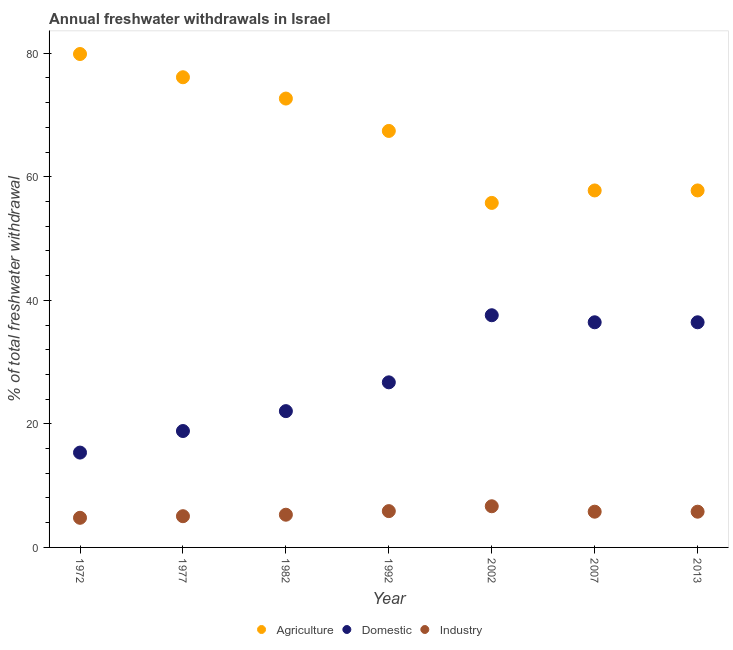Is the number of dotlines equal to the number of legend labels?
Keep it short and to the point. Yes. What is the percentage of freshwater withdrawal for agriculture in 1992?
Ensure brevity in your answer.  67.41. Across all years, what is the maximum percentage of freshwater withdrawal for agriculture?
Provide a succinct answer. 79.86. Across all years, what is the minimum percentage of freshwater withdrawal for agriculture?
Your response must be concise. 55.76. In which year was the percentage of freshwater withdrawal for industry maximum?
Your response must be concise. 2002. In which year was the percentage of freshwater withdrawal for industry minimum?
Your answer should be compact. 1972. What is the total percentage of freshwater withdrawal for industry in the graph?
Provide a short and direct response. 39.25. What is the difference between the percentage of freshwater withdrawal for domestic purposes in 1972 and that in 1982?
Offer a terse response. -6.71. What is the difference between the percentage of freshwater withdrawal for industry in 2007 and the percentage of freshwater withdrawal for agriculture in 2013?
Make the answer very short. -52. What is the average percentage of freshwater withdrawal for domestic purposes per year?
Offer a terse response. 27.63. In the year 2002, what is the difference between the percentage of freshwater withdrawal for domestic purposes and percentage of freshwater withdrawal for industry?
Make the answer very short. 30.92. What is the ratio of the percentage of freshwater withdrawal for industry in 1992 to that in 2013?
Provide a succinct answer. 1.02. What is the difference between the highest and the second highest percentage of freshwater withdrawal for agriculture?
Your response must be concise. 3.76. What is the difference between the highest and the lowest percentage of freshwater withdrawal for domestic purposes?
Offer a very short reply. 22.23. In how many years, is the percentage of freshwater withdrawal for domestic purposes greater than the average percentage of freshwater withdrawal for domestic purposes taken over all years?
Offer a very short reply. 3. Does the percentage of freshwater withdrawal for domestic purposes monotonically increase over the years?
Offer a terse response. No. How many dotlines are there?
Ensure brevity in your answer.  3. Are the values on the major ticks of Y-axis written in scientific E-notation?
Give a very brief answer. No. What is the title of the graph?
Provide a short and direct response. Annual freshwater withdrawals in Israel. What is the label or title of the Y-axis?
Keep it short and to the point. % of total freshwater withdrawal. What is the % of total freshwater withdrawal in Agriculture in 1972?
Your answer should be compact. 79.86. What is the % of total freshwater withdrawal in Domestic in 1972?
Give a very brief answer. 15.35. What is the % of total freshwater withdrawal of Industry in 1972?
Keep it short and to the point. 4.79. What is the % of total freshwater withdrawal in Agriculture in 1977?
Offer a very short reply. 76.1. What is the % of total freshwater withdrawal in Domestic in 1977?
Offer a very short reply. 18.84. What is the % of total freshwater withdrawal in Industry in 1977?
Provide a succinct answer. 5.05. What is the % of total freshwater withdrawal in Agriculture in 1982?
Ensure brevity in your answer.  72.65. What is the % of total freshwater withdrawal in Domestic in 1982?
Make the answer very short. 22.06. What is the % of total freshwater withdrawal of Industry in 1982?
Make the answer very short. 5.29. What is the % of total freshwater withdrawal in Agriculture in 1992?
Provide a short and direct response. 67.41. What is the % of total freshwater withdrawal in Domestic in 1992?
Provide a succinct answer. 26.72. What is the % of total freshwater withdrawal in Industry in 1992?
Provide a short and direct response. 5.88. What is the % of total freshwater withdrawal in Agriculture in 2002?
Provide a short and direct response. 55.76. What is the % of total freshwater withdrawal of Domestic in 2002?
Offer a very short reply. 37.58. What is the % of total freshwater withdrawal of Industry in 2002?
Provide a succinct answer. 6.66. What is the % of total freshwater withdrawal of Agriculture in 2007?
Make the answer very short. 57.78. What is the % of total freshwater withdrawal of Domestic in 2007?
Make the answer very short. 36.44. What is the % of total freshwater withdrawal of Industry in 2007?
Your response must be concise. 5.78. What is the % of total freshwater withdrawal of Agriculture in 2013?
Give a very brief answer. 57.78. What is the % of total freshwater withdrawal of Domestic in 2013?
Offer a very short reply. 36.44. What is the % of total freshwater withdrawal in Industry in 2013?
Your response must be concise. 5.78. Across all years, what is the maximum % of total freshwater withdrawal in Agriculture?
Ensure brevity in your answer.  79.86. Across all years, what is the maximum % of total freshwater withdrawal of Domestic?
Ensure brevity in your answer.  37.58. Across all years, what is the maximum % of total freshwater withdrawal in Industry?
Your answer should be very brief. 6.66. Across all years, what is the minimum % of total freshwater withdrawal of Agriculture?
Keep it short and to the point. 55.76. Across all years, what is the minimum % of total freshwater withdrawal in Domestic?
Provide a succinct answer. 15.35. Across all years, what is the minimum % of total freshwater withdrawal in Industry?
Your answer should be compact. 4.79. What is the total % of total freshwater withdrawal of Agriculture in the graph?
Keep it short and to the point. 467.34. What is the total % of total freshwater withdrawal in Domestic in the graph?
Your answer should be compact. 193.43. What is the total % of total freshwater withdrawal in Industry in the graph?
Make the answer very short. 39.25. What is the difference between the % of total freshwater withdrawal in Agriculture in 1972 and that in 1977?
Your answer should be very brief. 3.76. What is the difference between the % of total freshwater withdrawal of Domestic in 1972 and that in 1977?
Your response must be concise. -3.49. What is the difference between the % of total freshwater withdrawal of Industry in 1972 and that in 1977?
Give a very brief answer. -0.26. What is the difference between the % of total freshwater withdrawal of Agriculture in 1972 and that in 1982?
Your answer should be very brief. 7.21. What is the difference between the % of total freshwater withdrawal in Domestic in 1972 and that in 1982?
Ensure brevity in your answer.  -6.71. What is the difference between the % of total freshwater withdrawal in Industry in 1972 and that in 1982?
Provide a short and direct response. -0.5. What is the difference between the % of total freshwater withdrawal of Agriculture in 1972 and that in 1992?
Provide a short and direct response. 12.45. What is the difference between the % of total freshwater withdrawal of Domestic in 1972 and that in 1992?
Your answer should be very brief. -11.37. What is the difference between the % of total freshwater withdrawal of Industry in 1972 and that in 1992?
Your answer should be very brief. -1.08. What is the difference between the % of total freshwater withdrawal in Agriculture in 1972 and that in 2002?
Provide a short and direct response. 24.1. What is the difference between the % of total freshwater withdrawal in Domestic in 1972 and that in 2002?
Ensure brevity in your answer.  -22.23. What is the difference between the % of total freshwater withdrawal of Industry in 1972 and that in 2002?
Provide a succinct answer. -1.87. What is the difference between the % of total freshwater withdrawal in Agriculture in 1972 and that in 2007?
Give a very brief answer. 22.08. What is the difference between the % of total freshwater withdrawal of Domestic in 1972 and that in 2007?
Provide a succinct answer. -21.09. What is the difference between the % of total freshwater withdrawal of Industry in 1972 and that in 2007?
Your response must be concise. -0.99. What is the difference between the % of total freshwater withdrawal of Agriculture in 1972 and that in 2013?
Offer a very short reply. 22.08. What is the difference between the % of total freshwater withdrawal of Domestic in 1972 and that in 2013?
Your answer should be compact. -21.09. What is the difference between the % of total freshwater withdrawal in Industry in 1972 and that in 2013?
Keep it short and to the point. -0.99. What is the difference between the % of total freshwater withdrawal in Agriculture in 1977 and that in 1982?
Offer a very short reply. 3.45. What is the difference between the % of total freshwater withdrawal in Domestic in 1977 and that in 1982?
Ensure brevity in your answer.  -3.22. What is the difference between the % of total freshwater withdrawal in Industry in 1977 and that in 1982?
Make the answer very short. -0.24. What is the difference between the % of total freshwater withdrawal in Agriculture in 1977 and that in 1992?
Make the answer very short. 8.69. What is the difference between the % of total freshwater withdrawal in Domestic in 1977 and that in 1992?
Provide a succinct answer. -7.88. What is the difference between the % of total freshwater withdrawal in Industry in 1977 and that in 1992?
Make the answer very short. -0.82. What is the difference between the % of total freshwater withdrawal of Agriculture in 1977 and that in 2002?
Provide a short and direct response. 20.34. What is the difference between the % of total freshwater withdrawal in Domestic in 1977 and that in 2002?
Keep it short and to the point. -18.74. What is the difference between the % of total freshwater withdrawal of Industry in 1977 and that in 2002?
Provide a short and direct response. -1.61. What is the difference between the % of total freshwater withdrawal in Agriculture in 1977 and that in 2007?
Provide a succinct answer. 18.32. What is the difference between the % of total freshwater withdrawal in Domestic in 1977 and that in 2007?
Ensure brevity in your answer.  -17.6. What is the difference between the % of total freshwater withdrawal of Industry in 1977 and that in 2007?
Provide a short and direct response. -0.73. What is the difference between the % of total freshwater withdrawal in Agriculture in 1977 and that in 2013?
Offer a very short reply. 18.32. What is the difference between the % of total freshwater withdrawal of Domestic in 1977 and that in 2013?
Make the answer very short. -17.6. What is the difference between the % of total freshwater withdrawal in Industry in 1977 and that in 2013?
Make the answer very short. -0.73. What is the difference between the % of total freshwater withdrawal in Agriculture in 1982 and that in 1992?
Make the answer very short. 5.24. What is the difference between the % of total freshwater withdrawal of Domestic in 1982 and that in 1992?
Your response must be concise. -4.66. What is the difference between the % of total freshwater withdrawal of Industry in 1982 and that in 1992?
Keep it short and to the point. -0.58. What is the difference between the % of total freshwater withdrawal in Agriculture in 1982 and that in 2002?
Provide a short and direct response. 16.89. What is the difference between the % of total freshwater withdrawal in Domestic in 1982 and that in 2002?
Your response must be concise. -15.52. What is the difference between the % of total freshwater withdrawal of Industry in 1982 and that in 2002?
Provide a succinct answer. -1.37. What is the difference between the % of total freshwater withdrawal in Agriculture in 1982 and that in 2007?
Give a very brief answer. 14.87. What is the difference between the % of total freshwater withdrawal in Domestic in 1982 and that in 2007?
Your answer should be compact. -14.38. What is the difference between the % of total freshwater withdrawal in Industry in 1982 and that in 2007?
Make the answer very short. -0.49. What is the difference between the % of total freshwater withdrawal of Agriculture in 1982 and that in 2013?
Your answer should be very brief. 14.87. What is the difference between the % of total freshwater withdrawal of Domestic in 1982 and that in 2013?
Your answer should be very brief. -14.38. What is the difference between the % of total freshwater withdrawal in Industry in 1982 and that in 2013?
Provide a succinct answer. -0.49. What is the difference between the % of total freshwater withdrawal in Agriculture in 1992 and that in 2002?
Provide a succinct answer. 11.65. What is the difference between the % of total freshwater withdrawal in Domestic in 1992 and that in 2002?
Your answer should be compact. -10.86. What is the difference between the % of total freshwater withdrawal in Industry in 1992 and that in 2002?
Your answer should be very brief. -0.79. What is the difference between the % of total freshwater withdrawal in Agriculture in 1992 and that in 2007?
Your answer should be very brief. 9.63. What is the difference between the % of total freshwater withdrawal in Domestic in 1992 and that in 2007?
Make the answer very short. -9.72. What is the difference between the % of total freshwater withdrawal in Industry in 1992 and that in 2007?
Your answer should be compact. 0.09. What is the difference between the % of total freshwater withdrawal in Agriculture in 1992 and that in 2013?
Your response must be concise. 9.63. What is the difference between the % of total freshwater withdrawal of Domestic in 1992 and that in 2013?
Provide a short and direct response. -9.72. What is the difference between the % of total freshwater withdrawal of Industry in 1992 and that in 2013?
Offer a very short reply. 0.09. What is the difference between the % of total freshwater withdrawal in Agriculture in 2002 and that in 2007?
Provide a succinct answer. -2.02. What is the difference between the % of total freshwater withdrawal in Domestic in 2002 and that in 2007?
Offer a terse response. 1.14. What is the difference between the % of total freshwater withdrawal of Agriculture in 2002 and that in 2013?
Make the answer very short. -2.02. What is the difference between the % of total freshwater withdrawal of Domestic in 2002 and that in 2013?
Provide a short and direct response. 1.14. What is the difference between the % of total freshwater withdrawal of Industry in 2007 and that in 2013?
Provide a succinct answer. 0. What is the difference between the % of total freshwater withdrawal of Agriculture in 1972 and the % of total freshwater withdrawal of Domestic in 1977?
Offer a very short reply. 61.02. What is the difference between the % of total freshwater withdrawal of Agriculture in 1972 and the % of total freshwater withdrawal of Industry in 1977?
Ensure brevity in your answer.  74.81. What is the difference between the % of total freshwater withdrawal of Domestic in 1972 and the % of total freshwater withdrawal of Industry in 1977?
Your answer should be very brief. 10.29. What is the difference between the % of total freshwater withdrawal of Agriculture in 1972 and the % of total freshwater withdrawal of Domestic in 1982?
Offer a terse response. 57.8. What is the difference between the % of total freshwater withdrawal of Agriculture in 1972 and the % of total freshwater withdrawal of Industry in 1982?
Ensure brevity in your answer.  74.57. What is the difference between the % of total freshwater withdrawal of Domestic in 1972 and the % of total freshwater withdrawal of Industry in 1982?
Ensure brevity in your answer.  10.06. What is the difference between the % of total freshwater withdrawal in Agriculture in 1972 and the % of total freshwater withdrawal in Domestic in 1992?
Provide a succinct answer. 53.14. What is the difference between the % of total freshwater withdrawal in Agriculture in 1972 and the % of total freshwater withdrawal in Industry in 1992?
Provide a short and direct response. 73.98. What is the difference between the % of total freshwater withdrawal of Domestic in 1972 and the % of total freshwater withdrawal of Industry in 1992?
Provide a short and direct response. 9.47. What is the difference between the % of total freshwater withdrawal in Agriculture in 1972 and the % of total freshwater withdrawal in Domestic in 2002?
Your answer should be compact. 42.28. What is the difference between the % of total freshwater withdrawal of Agriculture in 1972 and the % of total freshwater withdrawal of Industry in 2002?
Your answer should be compact. 73.2. What is the difference between the % of total freshwater withdrawal of Domestic in 1972 and the % of total freshwater withdrawal of Industry in 2002?
Offer a terse response. 8.69. What is the difference between the % of total freshwater withdrawal of Agriculture in 1972 and the % of total freshwater withdrawal of Domestic in 2007?
Ensure brevity in your answer.  43.42. What is the difference between the % of total freshwater withdrawal of Agriculture in 1972 and the % of total freshwater withdrawal of Industry in 2007?
Give a very brief answer. 74.08. What is the difference between the % of total freshwater withdrawal in Domestic in 1972 and the % of total freshwater withdrawal in Industry in 2007?
Make the answer very short. 9.57. What is the difference between the % of total freshwater withdrawal of Agriculture in 1972 and the % of total freshwater withdrawal of Domestic in 2013?
Your answer should be compact. 43.42. What is the difference between the % of total freshwater withdrawal of Agriculture in 1972 and the % of total freshwater withdrawal of Industry in 2013?
Make the answer very short. 74.08. What is the difference between the % of total freshwater withdrawal in Domestic in 1972 and the % of total freshwater withdrawal in Industry in 2013?
Make the answer very short. 9.57. What is the difference between the % of total freshwater withdrawal of Agriculture in 1977 and the % of total freshwater withdrawal of Domestic in 1982?
Offer a very short reply. 54.04. What is the difference between the % of total freshwater withdrawal of Agriculture in 1977 and the % of total freshwater withdrawal of Industry in 1982?
Your response must be concise. 70.81. What is the difference between the % of total freshwater withdrawal in Domestic in 1977 and the % of total freshwater withdrawal in Industry in 1982?
Make the answer very short. 13.55. What is the difference between the % of total freshwater withdrawal in Agriculture in 1977 and the % of total freshwater withdrawal in Domestic in 1992?
Your answer should be very brief. 49.38. What is the difference between the % of total freshwater withdrawal in Agriculture in 1977 and the % of total freshwater withdrawal in Industry in 1992?
Your answer should be very brief. 70.22. What is the difference between the % of total freshwater withdrawal of Domestic in 1977 and the % of total freshwater withdrawal of Industry in 1992?
Provide a succinct answer. 12.96. What is the difference between the % of total freshwater withdrawal of Agriculture in 1977 and the % of total freshwater withdrawal of Domestic in 2002?
Offer a very short reply. 38.52. What is the difference between the % of total freshwater withdrawal of Agriculture in 1977 and the % of total freshwater withdrawal of Industry in 2002?
Ensure brevity in your answer.  69.44. What is the difference between the % of total freshwater withdrawal in Domestic in 1977 and the % of total freshwater withdrawal in Industry in 2002?
Provide a short and direct response. 12.18. What is the difference between the % of total freshwater withdrawal in Agriculture in 1977 and the % of total freshwater withdrawal in Domestic in 2007?
Provide a short and direct response. 39.66. What is the difference between the % of total freshwater withdrawal of Agriculture in 1977 and the % of total freshwater withdrawal of Industry in 2007?
Ensure brevity in your answer.  70.32. What is the difference between the % of total freshwater withdrawal in Domestic in 1977 and the % of total freshwater withdrawal in Industry in 2007?
Your answer should be very brief. 13.06. What is the difference between the % of total freshwater withdrawal in Agriculture in 1977 and the % of total freshwater withdrawal in Domestic in 2013?
Your answer should be compact. 39.66. What is the difference between the % of total freshwater withdrawal in Agriculture in 1977 and the % of total freshwater withdrawal in Industry in 2013?
Your response must be concise. 70.32. What is the difference between the % of total freshwater withdrawal in Domestic in 1977 and the % of total freshwater withdrawal in Industry in 2013?
Make the answer very short. 13.06. What is the difference between the % of total freshwater withdrawal of Agriculture in 1982 and the % of total freshwater withdrawal of Domestic in 1992?
Keep it short and to the point. 45.93. What is the difference between the % of total freshwater withdrawal of Agriculture in 1982 and the % of total freshwater withdrawal of Industry in 1992?
Give a very brief answer. 66.77. What is the difference between the % of total freshwater withdrawal of Domestic in 1982 and the % of total freshwater withdrawal of Industry in 1992?
Make the answer very short. 16.18. What is the difference between the % of total freshwater withdrawal in Agriculture in 1982 and the % of total freshwater withdrawal in Domestic in 2002?
Give a very brief answer. 35.07. What is the difference between the % of total freshwater withdrawal of Agriculture in 1982 and the % of total freshwater withdrawal of Industry in 2002?
Your answer should be compact. 65.99. What is the difference between the % of total freshwater withdrawal of Domestic in 1982 and the % of total freshwater withdrawal of Industry in 2002?
Offer a terse response. 15.4. What is the difference between the % of total freshwater withdrawal in Agriculture in 1982 and the % of total freshwater withdrawal in Domestic in 2007?
Your answer should be very brief. 36.21. What is the difference between the % of total freshwater withdrawal of Agriculture in 1982 and the % of total freshwater withdrawal of Industry in 2007?
Offer a very short reply. 66.87. What is the difference between the % of total freshwater withdrawal in Domestic in 1982 and the % of total freshwater withdrawal in Industry in 2007?
Provide a short and direct response. 16.28. What is the difference between the % of total freshwater withdrawal of Agriculture in 1982 and the % of total freshwater withdrawal of Domestic in 2013?
Your answer should be very brief. 36.21. What is the difference between the % of total freshwater withdrawal of Agriculture in 1982 and the % of total freshwater withdrawal of Industry in 2013?
Offer a terse response. 66.87. What is the difference between the % of total freshwater withdrawal in Domestic in 1982 and the % of total freshwater withdrawal in Industry in 2013?
Make the answer very short. 16.28. What is the difference between the % of total freshwater withdrawal in Agriculture in 1992 and the % of total freshwater withdrawal in Domestic in 2002?
Your answer should be compact. 29.83. What is the difference between the % of total freshwater withdrawal of Agriculture in 1992 and the % of total freshwater withdrawal of Industry in 2002?
Offer a terse response. 60.75. What is the difference between the % of total freshwater withdrawal in Domestic in 1992 and the % of total freshwater withdrawal in Industry in 2002?
Provide a short and direct response. 20.06. What is the difference between the % of total freshwater withdrawal in Agriculture in 1992 and the % of total freshwater withdrawal in Domestic in 2007?
Offer a terse response. 30.97. What is the difference between the % of total freshwater withdrawal in Agriculture in 1992 and the % of total freshwater withdrawal in Industry in 2007?
Your answer should be compact. 61.63. What is the difference between the % of total freshwater withdrawal of Domestic in 1992 and the % of total freshwater withdrawal of Industry in 2007?
Provide a short and direct response. 20.94. What is the difference between the % of total freshwater withdrawal of Agriculture in 1992 and the % of total freshwater withdrawal of Domestic in 2013?
Provide a succinct answer. 30.97. What is the difference between the % of total freshwater withdrawal in Agriculture in 1992 and the % of total freshwater withdrawal in Industry in 2013?
Offer a very short reply. 61.63. What is the difference between the % of total freshwater withdrawal in Domestic in 1992 and the % of total freshwater withdrawal in Industry in 2013?
Your response must be concise. 20.94. What is the difference between the % of total freshwater withdrawal in Agriculture in 2002 and the % of total freshwater withdrawal in Domestic in 2007?
Your answer should be compact. 19.32. What is the difference between the % of total freshwater withdrawal of Agriculture in 2002 and the % of total freshwater withdrawal of Industry in 2007?
Offer a very short reply. 49.98. What is the difference between the % of total freshwater withdrawal of Domestic in 2002 and the % of total freshwater withdrawal of Industry in 2007?
Keep it short and to the point. 31.8. What is the difference between the % of total freshwater withdrawal in Agriculture in 2002 and the % of total freshwater withdrawal in Domestic in 2013?
Make the answer very short. 19.32. What is the difference between the % of total freshwater withdrawal of Agriculture in 2002 and the % of total freshwater withdrawal of Industry in 2013?
Your response must be concise. 49.98. What is the difference between the % of total freshwater withdrawal of Domestic in 2002 and the % of total freshwater withdrawal of Industry in 2013?
Provide a short and direct response. 31.8. What is the difference between the % of total freshwater withdrawal of Agriculture in 2007 and the % of total freshwater withdrawal of Domestic in 2013?
Your response must be concise. 21.34. What is the difference between the % of total freshwater withdrawal in Agriculture in 2007 and the % of total freshwater withdrawal in Industry in 2013?
Keep it short and to the point. 52. What is the difference between the % of total freshwater withdrawal of Domestic in 2007 and the % of total freshwater withdrawal of Industry in 2013?
Give a very brief answer. 30.66. What is the average % of total freshwater withdrawal in Agriculture per year?
Offer a terse response. 66.76. What is the average % of total freshwater withdrawal in Domestic per year?
Provide a short and direct response. 27.63. What is the average % of total freshwater withdrawal in Industry per year?
Offer a very short reply. 5.61. In the year 1972, what is the difference between the % of total freshwater withdrawal in Agriculture and % of total freshwater withdrawal in Domestic?
Make the answer very short. 64.51. In the year 1972, what is the difference between the % of total freshwater withdrawal of Agriculture and % of total freshwater withdrawal of Industry?
Provide a succinct answer. 75.06. In the year 1972, what is the difference between the % of total freshwater withdrawal of Domestic and % of total freshwater withdrawal of Industry?
Provide a succinct answer. 10.55. In the year 1977, what is the difference between the % of total freshwater withdrawal of Agriculture and % of total freshwater withdrawal of Domestic?
Your answer should be compact. 57.26. In the year 1977, what is the difference between the % of total freshwater withdrawal in Agriculture and % of total freshwater withdrawal in Industry?
Your answer should be compact. 71.05. In the year 1977, what is the difference between the % of total freshwater withdrawal of Domestic and % of total freshwater withdrawal of Industry?
Provide a short and direct response. 13.79. In the year 1982, what is the difference between the % of total freshwater withdrawal in Agriculture and % of total freshwater withdrawal in Domestic?
Make the answer very short. 50.59. In the year 1982, what is the difference between the % of total freshwater withdrawal in Agriculture and % of total freshwater withdrawal in Industry?
Make the answer very short. 67.36. In the year 1982, what is the difference between the % of total freshwater withdrawal of Domestic and % of total freshwater withdrawal of Industry?
Keep it short and to the point. 16.77. In the year 1992, what is the difference between the % of total freshwater withdrawal in Agriculture and % of total freshwater withdrawal in Domestic?
Your answer should be very brief. 40.69. In the year 1992, what is the difference between the % of total freshwater withdrawal of Agriculture and % of total freshwater withdrawal of Industry?
Make the answer very short. 61.53. In the year 1992, what is the difference between the % of total freshwater withdrawal in Domestic and % of total freshwater withdrawal in Industry?
Keep it short and to the point. 20.84. In the year 2002, what is the difference between the % of total freshwater withdrawal of Agriculture and % of total freshwater withdrawal of Domestic?
Make the answer very short. 18.18. In the year 2002, what is the difference between the % of total freshwater withdrawal in Agriculture and % of total freshwater withdrawal in Industry?
Keep it short and to the point. 49.1. In the year 2002, what is the difference between the % of total freshwater withdrawal of Domestic and % of total freshwater withdrawal of Industry?
Keep it short and to the point. 30.92. In the year 2007, what is the difference between the % of total freshwater withdrawal of Agriculture and % of total freshwater withdrawal of Domestic?
Offer a terse response. 21.34. In the year 2007, what is the difference between the % of total freshwater withdrawal in Agriculture and % of total freshwater withdrawal in Industry?
Your answer should be compact. 52. In the year 2007, what is the difference between the % of total freshwater withdrawal of Domestic and % of total freshwater withdrawal of Industry?
Your answer should be compact. 30.66. In the year 2013, what is the difference between the % of total freshwater withdrawal in Agriculture and % of total freshwater withdrawal in Domestic?
Offer a very short reply. 21.34. In the year 2013, what is the difference between the % of total freshwater withdrawal of Agriculture and % of total freshwater withdrawal of Industry?
Give a very brief answer. 52. In the year 2013, what is the difference between the % of total freshwater withdrawal in Domestic and % of total freshwater withdrawal in Industry?
Give a very brief answer. 30.66. What is the ratio of the % of total freshwater withdrawal in Agriculture in 1972 to that in 1977?
Your answer should be compact. 1.05. What is the ratio of the % of total freshwater withdrawal of Domestic in 1972 to that in 1977?
Provide a short and direct response. 0.81. What is the ratio of the % of total freshwater withdrawal of Industry in 1972 to that in 1977?
Offer a terse response. 0.95. What is the ratio of the % of total freshwater withdrawal in Agriculture in 1972 to that in 1982?
Your answer should be compact. 1.1. What is the ratio of the % of total freshwater withdrawal in Domestic in 1972 to that in 1982?
Provide a succinct answer. 0.7. What is the ratio of the % of total freshwater withdrawal of Industry in 1972 to that in 1982?
Keep it short and to the point. 0.91. What is the ratio of the % of total freshwater withdrawal of Agriculture in 1972 to that in 1992?
Keep it short and to the point. 1.18. What is the ratio of the % of total freshwater withdrawal in Domestic in 1972 to that in 1992?
Provide a short and direct response. 0.57. What is the ratio of the % of total freshwater withdrawal of Industry in 1972 to that in 1992?
Your answer should be very brief. 0.82. What is the ratio of the % of total freshwater withdrawal of Agriculture in 1972 to that in 2002?
Offer a terse response. 1.43. What is the ratio of the % of total freshwater withdrawal of Domestic in 1972 to that in 2002?
Keep it short and to the point. 0.41. What is the ratio of the % of total freshwater withdrawal of Industry in 1972 to that in 2002?
Give a very brief answer. 0.72. What is the ratio of the % of total freshwater withdrawal of Agriculture in 1972 to that in 2007?
Make the answer very short. 1.38. What is the ratio of the % of total freshwater withdrawal in Domestic in 1972 to that in 2007?
Offer a terse response. 0.42. What is the ratio of the % of total freshwater withdrawal in Industry in 1972 to that in 2007?
Keep it short and to the point. 0.83. What is the ratio of the % of total freshwater withdrawal of Agriculture in 1972 to that in 2013?
Your answer should be compact. 1.38. What is the ratio of the % of total freshwater withdrawal in Domestic in 1972 to that in 2013?
Provide a succinct answer. 0.42. What is the ratio of the % of total freshwater withdrawal in Industry in 1972 to that in 2013?
Offer a terse response. 0.83. What is the ratio of the % of total freshwater withdrawal of Agriculture in 1977 to that in 1982?
Your answer should be very brief. 1.05. What is the ratio of the % of total freshwater withdrawal in Domestic in 1977 to that in 1982?
Keep it short and to the point. 0.85. What is the ratio of the % of total freshwater withdrawal of Industry in 1977 to that in 1982?
Keep it short and to the point. 0.95. What is the ratio of the % of total freshwater withdrawal of Agriculture in 1977 to that in 1992?
Give a very brief answer. 1.13. What is the ratio of the % of total freshwater withdrawal in Domestic in 1977 to that in 1992?
Your answer should be very brief. 0.71. What is the ratio of the % of total freshwater withdrawal of Industry in 1977 to that in 1992?
Offer a terse response. 0.86. What is the ratio of the % of total freshwater withdrawal of Agriculture in 1977 to that in 2002?
Provide a succinct answer. 1.36. What is the ratio of the % of total freshwater withdrawal of Domestic in 1977 to that in 2002?
Your answer should be compact. 0.5. What is the ratio of the % of total freshwater withdrawal of Industry in 1977 to that in 2002?
Your answer should be compact. 0.76. What is the ratio of the % of total freshwater withdrawal of Agriculture in 1977 to that in 2007?
Offer a very short reply. 1.32. What is the ratio of the % of total freshwater withdrawal of Domestic in 1977 to that in 2007?
Give a very brief answer. 0.52. What is the ratio of the % of total freshwater withdrawal in Industry in 1977 to that in 2007?
Your response must be concise. 0.87. What is the ratio of the % of total freshwater withdrawal in Agriculture in 1977 to that in 2013?
Your answer should be very brief. 1.32. What is the ratio of the % of total freshwater withdrawal in Domestic in 1977 to that in 2013?
Make the answer very short. 0.52. What is the ratio of the % of total freshwater withdrawal of Industry in 1977 to that in 2013?
Offer a terse response. 0.87. What is the ratio of the % of total freshwater withdrawal of Agriculture in 1982 to that in 1992?
Provide a succinct answer. 1.08. What is the ratio of the % of total freshwater withdrawal of Domestic in 1982 to that in 1992?
Your response must be concise. 0.83. What is the ratio of the % of total freshwater withdrawal in Industry in 1982 to that in 1992?
Make the answer very short. 0.9. What is the ratio of the % of total freshwater withdrawal in Agriculture in 1982 to that in 2002?
Provide a succinct answer. 1.3. What is the ratio of the % of total freshwater withdrawal in Domestic in 1982 to that in 2002?
Provide a succinct answer. 0.59. What is the ratio of the % of total freshwater withdrawal of Industry in 1982 to that in 2002?
Keep it short and to the point. 0.79. What is the ratio of the % of total freshwater withdrawal of Agriculture in 1982 to that in 2007?
Give a very brief answer. 1.26. What is the ratio of the % of total freshwater withdrawal in Domestic in 1982 to that in 2007?
Your answer should be compact. 0.61. What is the ratio of the % of total freshwater withdrawal of Industry in 1982 to that in 2007?
Make the answer very short. 0.92. What is the ratio of the % of total freshwater withdrawal in Agriculture in 1982 to that in 2013?
Your response must be concise. 1.26. What is the ratio of the % of total freshwater withdrawal in Domestic in 1982 to that in 2013?
Ensure brevity in your answer.  0.61. What is the ratio of the % of total freshwater withdrawal of Industry in 1982 to that in 2013?
Your answer should be compact. 0.92. What is the ratio of the % of total freshwater withdrawal in Agriculture in 1992 to that in 2002?
Your answer should be compact. 1.21. What is the ratio of the % of total freshwater withdrawal of Domestic in 1992 to that in 2002?
Your response must be concise. 0.71. What is the ratio of the % of total freshwater withdrawal in Industry in 1992 to that in 2002?
Your answer should be compact. 0.88. What is the ratio of the % of total freshwater withdrawal in Domestic in 1992 to that in 2007?
Give a very brief answer. 0.73. What is the ratio of the % of total freshwater withdrawal of Industry in 1992 to that in 2007?
Provide a succinct answer. 1.02. What is the ratio of the % of total freshwater withdrawal of Domestic in 1992 to that in 2013?
Your answer should be very brief. 0.73. What is the ratio of the % of total freshwater withdrawal of Industry in 1992 to that in 2013?
Keep it short and to the point. 1.02. What is the ratio of the % of total freshwater withdrawal of Agriculture in 2002 to that in 2007?
Offer a terse response. 0.96. What is the ratio of the % of total freshwater withdrawal of Domestic in 2002 to that in 2007?
Ensure brevity in your answer.  1.03. What is the ratio of the % of total freshwater withdrawal in Industry in 2002 to that in 2007?
Offer a terse response. 1.15. What is the ratio of the % of total freshwater withdrawal of Agriculture in 2002 to that in 2013?
Keep it short and to the point. 0.96. What is the ratio of the % of total freshwater withdrawal of Domestic in 2002 to that in 2013?
Keep it short and to the point. 1.03. What is the ratio of the % of total freshwater withdrawal in Industry in 2002 to that in 2013?
Ensure brevity in your answer.  1.15. What is the ratio of the % of total freshwater withdrawal of Domestic in 2007 to that in 2013?
Offer a terse response. 1. What is the difference between the highest and the second highest % of total freshwater withdrawal of Agriculture?
Ensure brevity in your answer.  3.76. What is the difference between the highest and the second highest % of total freshwater withdrawal of Domestic?
Your answer should be compact. 1.14. What is the difference between the highest and the second highest % of total freshwater withdrawal in Industry?
Provide a succinct answer. 0.79. What is the difference between the highest and the lowest % of total freshwater withdrawal in Agriculture?
Provide a short and direct response. 24.1. What is the difference between the highest and the lowest % of total freshwater withdrawal of Domestic?
Provide a short and direct response. 22.23. What is the difference between the highest and the lowest % of total freshwater withdrawal in Industry?
Your answer should be compact. 1.87. 